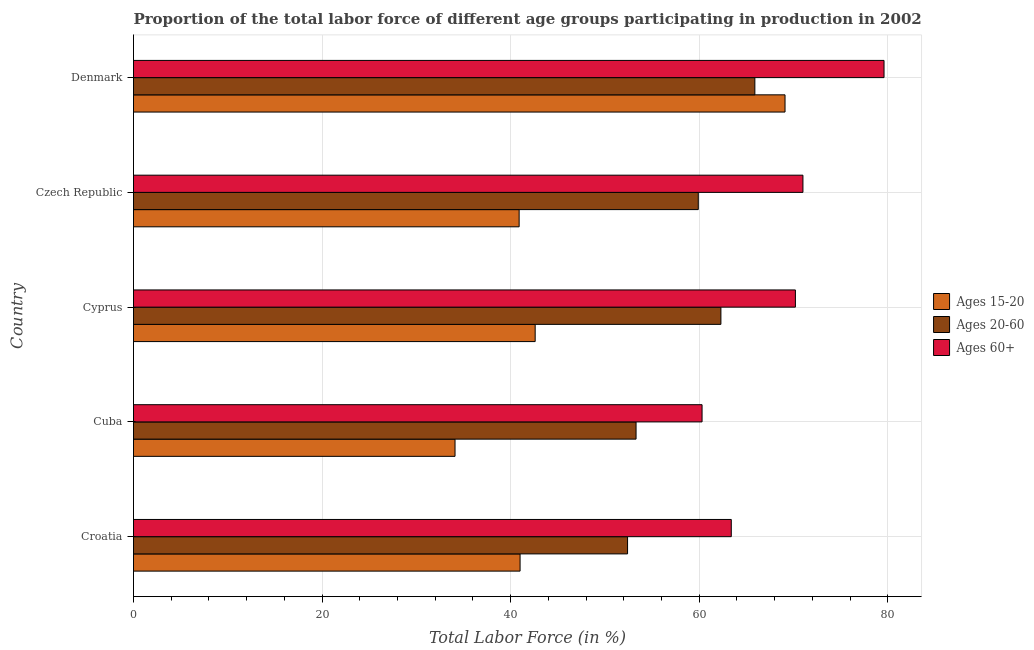Are the number of bars on each tick of the Y-axis equal?
Offer a terse response. Yes. How many bars are there on the 5th tick from the top?
Offer a very short reply. 3. How many bars are there on the 1st tick from the bottom?
Keep it short and to the point. 3. What is the label of the 4th group of bars from the top?
Provide a succinct answer. Cuba. In how many cases, is the number of bars for a given country not equal to the number of legend labels?
Offer a very short reply. 0. What is the percentage of labor force within the age group 20-60 in Denmark?
Your answer should be compact. 65.9. Across all countries, what is the maximum percentage of labor force above age 60?
Give a very brief answer. 79.6. Across all countries, what is the minimum percentage of labor force above age 60?
Ensure brevity in your answer.  60.3. In which country was the percentage of labor force within the age group 20-60 maximum?
Provide a succinct answer. Denmark. In which country was the percentage of labor force within the age group 20-60 minimum?
Offer a terse response. Croatia. What is the total percentage of labor force above age 60 in the graph?
Your response must be concise. 344.5. What is the difference between the percentage of labor force within the age group 20-60 in Croatia and the percentage of labor force above age 60 in Denmark?
Provide a succinct answer. -27.2. What is the average percentage of labor force within the age group 20-60 per country?
Your response must be concise. 58.76. What is the difference between the percentage of labor force above age 60 and percentage of labor force within the age group 15-20 in Cyprus?
Your response must be concise. 27.6. Is the percentage of labor force above age 60 in Croatia less than that in Cuba?
Offer a very short reply. No. What is the difference between the highest and the second highest percentage of labor force within the age group 20-60?
Make the answer very short. 3.6. What is the difference between the highest and the lowest percentage of labor force above age 60?
Keep it short and to the point. 19.3. In how many countries, is the percentage of labor force within the age group 20-60 greater than the average percentage of labor force within the age group 20-60 taken over all countries?
Offer a terse response. 3. What does the 2nd bar from the top in Cuba represents?
Your answer should be compact. Ages 20-60. What does the 2nd bar from the bottom in Cyprus represents?
Your answer should be compact. Ages 20-60. Is it the case that in every country, the sum of the percentage of labor force within the age group 15-20 and percentage of labor force within the age group 20-60 is greater than the percentage of labor force above age 60?
Make the answer very short. Yes. How many bars are there?
Ensure brevity in your answer.  15. How many countries are there in the graph?
Offer a terse response. 5. What is the difference between two consecutive major ticks on the X-axis?
Give a very brief answer. 20. Does the graph contain grids?
Give a very brief answer. Yes. How many legend labels are there?
Your response must be concise. 3. How are the legend labels stacked?
Your answer should be very brief. Vertical. What is the title of the graph?
Offer a terse response. Proportion of the total labor force of different age groups participating in production in 2002. What is the label or title of the X-axis?
Provide a succinct answer. Total Labor Force (in %). What is the label or title of the Y-axis?
Provide a short and direct response. Country. What is the Total Labor Force (in %) of Ages 20-60 in Croatia?
Keep it short and to the point. 52.4. What is the Total Labor Force (in %) of Ages 60+ in Croatia?
Provide a short and direct response. 63.4. What is the Total Labor Force (in %) in Ages 15-20 in Cuba?
Make the answer very short. 34.1. What is the Total Labor Force (in %) of Ages 20-60 in Cuba?
Your answer should be very brief. 53.3. What is the Total Labor Force (in %) in Ages 60+ in Cuba?
Provide a succinct answer. 60.3. What is the Total Labor Force (in %) of Ages 15-20 in Cyprus?
Provide a short and direct response. 42.6. What is the Total Labor Force (in %) in Ages 20-60 in Cyprus?
Keep it short and to the point. 62.3. What is the Total Labor Force (in %) of Ages 60+ in Cyprus?
Ensure brevity in your answer.  70.2. What is the Total Labor Force (in %) in Ages 15-20 in Czech Republic?
Ensure brevity in your answer.  40.9. What is the Total Labor Force (in %) of Ages 20-60 in Czech Republic?
Your response must be concise. 59.9. What is the Total Labor Force (in %) in Ages 60+ in Czech Republic?
Your answer should be very brief. 71. What is the Total Labor Force (in %) of Ages 15-20 in Denmark?
Your answer should be compact. 69.1. What is the Total Labor Force (in %) in Ages 20-60 in Denmark?
Your answer should be very brief. 65.9. What is the Total Labor Force (in %) in Ages 60+ in Denmark?
Offer a terse response. 79.6. Across all countries, what is the maximum Total Labor Force (in %) of Ages 15-20?
Your answer should be very brief. 69.1. Across all countries, what is the maximum Total Labor Force (in %) of Ages 20-60?
Make the answer very short. 65.9. Across all countries, what is the maximum Total Labor Force (in %) in Ages 60+?
Your response must be concise. 79.6. Across all countries, what is the minimum Total Labor Force (in %) in Ages 15-20?
Give a very brief answer. 34.1. Across all countries, what is the minimum Total Labor Force (in %) of Ages 20-60?
Provide a succinct answer. 52.4. Across all countries, what is the minimum Total Labor Force (in %) in Ages 60+?
Offer a terse response. 60.3. What is the total Total Labor Force (in %) of Ages 15-20 in the graph?
Your response must be concise. 227.7. What is the total Total Labor Force (in %) in Ages 20-60 in the graph?
Give a very brief answer. 293.8. What is the total Total Labor Force (in %) of Ages 60+ in the graph?
Ensure brevity in your answer.  344.5. What is the difference between the Total Labor Force (in %) of Ages 15-20 in Croatia and that in Cuba?
Ensure brevity in your answer.  6.9. What is the difference between the Total Labor Force (in %) of Ages 20-60 in Croatia and that in Cuba?
Ensure brevity in your answer.  -0.9. What is the difference between the Total Labor Force (in %) of Ages 60+ in Croatia and that in Cuba?
Give a very brief answer. 3.1. What is the difference between the Total Labor Force (in %) of Ages 15-20 in Croatia and that in Cyprus?
Offer a very short reply. -1.6. What is the difference between the Total Labor Force (in %) of Ages 15-20 in Croatia and that in Czech Republic?
Your response must be concise. 0.1. What is the difference between the Total Labor Force (in %) in Ages 20-60 in Croatia and that in Czech Republic?
Provide a succinct answer. -7.5. What is the difference between the Total Labor Force (in %) in Ages 60+ in Croatia and that in Czech Republic?
Give a very brief answer. -7.6. What is the difference between the Total Labor Force (in %) of Ages 15-20 in Croatia and that in Denmark?
Give a very brief answer. -28.1. What is the difference between the Total Labor Force (in %) of Ages 60+ in Croatia and that in Denmark?
Your response must be concise. -16.2. What is the difference between the Total Labor Force (in %) of Ages 15-20 in Cuba and that in Cyprus?
Your answer should be compact. -8.5. What is the difference between the Total Labor Force (in %) in Ages 60+ in Cuba and that in Cyprus?
Offer a terse response. -9.9. What is the difference between the Total Labor Force (in %) of Ages 20-60 in Cuba and that in Czech Republic?
Offer a very short reply. -6.6. What is the difference between the Total Labor Force (in %) in Ages 15-20 in Cuba and that in Denmark?
Your response must be concise. -35. What is the difference between the Total Labor Force (in %) of Ages 20-60 in Cuba and that in Denmark?
Offer a very short reply. -12.6. What is the difference between the Total Labor Force (in %) in Ages 60+ in Cuba and that in Denmark?
Offer a terse response. -19.3. What is the difference between the Total Labor Force (in %) of Ages 15-20 in Cyprus and that in Czech Republic?
Your answer should be very brief. 1.7. What is the difference between the Total Labor Force (in %) in Ages 60+ in Cyprus and that in Czech Republic?
Offer a terse response. -0.8. What is the difference between the Total Labor Force (in %) of Ages 15-20 in Cyprus and that in Denmark?
Provide a short and direct response. -26.5. What is the difference between the Total Labor Force (in %) in Ages 20-60 in Cyprus and that in Denmark?
Provide a succinct answer. -3.6. What is the difference between the Total Labor Force (in %) in Ages 60+ in Cyprus and that in Denmark?
Give a very brief answer. -9.4. What is the difference between the Total Labor Force (in %) in Ages 15-20 in Czech Republic and that in Denmark?
Provide a succinct answer. -28.2. What is the difference between the Total Labor Force (in %) in Ages 60+ in Czech Republic and that in Denmark?
Your answer should be very brief. -8.6. What is the difference between the Total Labor Force (in %) of Ages 15-20 in Croatia and the Total Labor Force (in %) of Ages 60+ in Cuba?
Keep it short and to the point. -19.3. What is the difference between the Total Labor Force (in %) of Ages 15-20 in Croatia and the Total Labor Force (in %) of Ages 20-60 in Cyprus?
Offer a terse response. -21.3. What is the difference between the Total Labor Force (in %) in Ages 15-20 in Croatia and the Total Labor Force (in %) in Ages 60+ in Cyprus?
Your answer should be very brief. -29.2. What is the difference between the Total Labor Force (in %) in Ages 20-60 in Croatia and the Total Labor Force (in %) in Ages 60+ in Cyprus?
Ensure brevity in your answer.  -17.8. What is the difference between the Total Labor Force (in %) in Ages 15-20 in Croatia and the Total Labor Force (in %) in Ages 20-60 in Czech Republic?
Your answer should be very brief. -18.9. What is the difference between the Total Labor Force (in %) of Ages 20-60 in Croatia and the Total Labor Force (in %) of Ages 60+ in Czech Republic?
Ensure brevity in your answer.  -18.6. What is the difference between the Total Labor Force (in %) in Ages 15-20 in Croatia and the Total Labor Force (in %) in Ages 20-60 in Denmark?
Provide a succinct answer. -24.9. What is the difference between the Total Labor Force (in %) in Ages 15-20 in Croatia and the Total Labor Force (in %) in Ages 60+ in Denmark?
Your response must be concise. -38.6. What is the difference between the Total Labor Force (in %) of Ages 20-60 in Croatia and the Total Labor Force (in %) of Ages 60+ in Denmark?
Give a very brief answer. -27.2. What is the difference between the Total Labor Force (in %) in Ages 15-20 in Cuba and the Total Labor Force (in %) in Ages 20-60 in Cyprus?
Keep it short and to the point. -28.2. What is the difference between the Total Labor Force (in %) in Ages 15-20 in Cuba and the Total Labor Force (in %) in Ages 60+ in Cyprus?
Give a very brief answer. -36.1. What is the difference between the Total Labor Force (in %) of Ages 20-60 in Cuba and the Total Labor Force (in %) of Ages 60+ in Cyprus?
Keep it short and to the point. -16.9. What is the difference between the Total Labor Force (in %) of Ages 15-20 in Cuba and the Total Labor Force (in %) of Ages 20-60 in Czech Republic?
Ensure brevity in your answer.  -25.8. What is the difference between the Total Labor Force (in %) of Ages 15-20 in Cuba and the Total Labor Force (in %) of Ages 60+ in Czech Republic?
Make the answer very short. -36.9. What is the difference between the Total Labor Force (in %) of Ages 20-60 in Cuba and the Total Labor Force (in %) of Ages 60+ in Czech Republic?
Provide a succinct answer. -17.7. What is the difference between the Total Labor Force (in %) of Ages 15-20 in Cuba and the Total Labor Force (in %) of Ages 20-60 in Denmark?
Your response must be concise. -31.8. What is the difference between the Total Labor Force (in %) in Ages 15-20 in Cuba and the Total Labor Force (in %) in Ages 60+ in Denmark?
Offer a terse response. -45.5. What is the difference between the Total Labor Force (in %) in Ages 20-60 in Cuba and the Total Labor Force (in %) in Ages 60+ in Denmark?
Your response must be concise. -26.3. What is the difference between the Total Labor Force (in %) of Ages 15-20 in Cyprus and the Total Labor Force (in %) of Ages 20-60 in Czech Republic?
Provide a short and direct response. -17.3. What is the difference between the Total Labor Force (in %) of Ages 15-20 in Cyprus and the Total Labor Force (in %) of Ages 60+ in Czech Republic?
Keep it short and to the point. -28.4. What is the difference between the Total Labor Force (in %) in Ages 15-20 in Cyprus and the Total Labor Force (in %) in Ages 20-60 in Denmark?
Provide a short and direct response. -23.3. What is the difference between the Total Labor Force (in %) in Ages 15-20 in Cyprus and the Total Labor Force (in %) in Ages 60+ in Denmark?
Ensure brevity in your answer.  -37. What is the difference between the Total Labor Force (in %) in Ages 20-60 in Cyprus and the Total Labor Force (in %) in Ages 60+ in Denmark?
Ensure brevity in your answer.  -17.3. What is the difference between the Total Labor Force (in %) in Ages 15-20 in Czech Republic and the Total Labor Force (in %) in Ages 20-60 in Denmark?
Provide a succinct answer. -25. What is the difference between the Total Labor Force (in %) in Ages 15-20 in Czech Republic and the Total Labor Force (in %) in Ages 60+ in Denmark?
Provide a short and direct response. -38.7. What is the difference between the Total Labor Force (in %) of Ages 20-60 in Czech Republic and the Total Labor Force (in %) of Ages 60+ in Denmark?
Provide a short and direct response. -19.7. What is the average Total Labor Force (in %) of Ages 15-20 per country?
Offer a very short reply. 45.54. What is the average Total Labor Force (in %) in Ages 20-60 per country?
Give a very brief answer. 58.76. What is the average Total Labor Force (in %) in Ages 60+ per country?
Keep it short and to the point. 68.9. What is the difference between the Total Labor Force (in %) in Ages 15-20 and Total Labor Force (in %) in Ages 60+ in Croatia?
Keep it short and to the point. -22.4. What is the difference between the Total Labor Force (in %) in Ages 20-60 and Total Labor Force (in %) in Ages 60+ in Croatia?
Keep it short and to the point. -11. What is the difference between the Total Labor Force (in %) of Ages 15-20 and Total Labor Force (in %) of Ages 20-60 in Cuba?
Your response must be concise. -19.2. What is the difference between the Total Labor Force (in %) of Ages 15-20 and Total Labor Force (in %) of Ages 60+ in Cuba?
Keep it short and to the point. -26.2. What is the difference between the Total Labor Force (in %) in Ages 15-20 and Total Labor Force (in %) in Ages 20-60 in Cyprus?
Make the answer very short. -19.7. What is the difference between the Total Labor Force (in %) of Ages 15-20 and Total Labor Force (in %) of Ages 60+ in Cyprus?
Provide a short and direct response. -27.6. What is the difference between the Total Labor Force (in %) of Ages 15-20 and Total Labor Force (in %) of Ages 60+ in Czech Republic?
Provide a succinct answer. -30.1. What is the difference between the Total Labor Force (in %) of Ages 15-20 and Total Labor Force (in %) of Ages 20-60 in Denmark?
Provide a succinct answer. 3.2. What is the difference between the Total Labor Force (in %) of Ages 20-60 and Total Labor Force (in %) of Ages 60+ in Denmark?
Your answer should be very brief. -13.7. What is the ratio of the Total Labor Force (in %) in Ages 15-20 in Croatia to that in Cuba?
Make the answer very short. 1.2. What is the ratio of the Total Labor Force (in %) in Ages 20-60 in Croatia to that in Cuba?
Make the answer very short. 0.98. What is the ratio of the Total Labor Force (in %) in Ages 60+ in Croatia to that in Cuba?
Keep it short and to the point. 1.05. What is the ratio of the Total Labor Force (in %) in Ages 15-20 in Croatia to that in Cyprus?
Offer a terse response. 0.96. What is the ratio of the Total Labor Force (in %) of Ages 20-60 in Croatia to that in Cyprus?
Offer a terse response. 0.84. What is the ratio of the Total Labor Force (in %) in Ages 60+ in Croatia to that in Cyprus?
Offer a terse response. 0.9. What is the ratio of the Total Labor Force (in %) of Ages 15-20 in Croatia to that in Czech Republic?
Make the answer very short. 1. What is the ratio of the Total Labor Force (in %) in Ages 20-60 in Croatia to that in Czech Republic?
Your answer should be compact. 0.87. What is the ratio of the Total Labor Force (in %) of Ages 60+ in Croatia to that in Czech Republic?
Make the answer very short. 0.89. What is the ratio of the Total Labor Force (in %) in Ages 15-20 in Croatia to that in Denmark?
Provide a succinct answer. 0.59. What is the ratio of the Total Labor Force (in %) in Ages 20-60 in Croatia to that in Denmark?
Your answer should be very brief. 0.8. What is the ratio of the Total Labor Force (in %) in Ages 60+ in Croatia to that in Denmark?
Ensure brevity in your answer.  0.8. What is the ratio of the Total Labor Force (in %) of Ages 15-20 in Cuba to that in Cyprus?
Offer a very short reply. 0.8. What is the ratio of the Total Labor Force (in %) of Ages 20-60 in Cuba to that in Cyprus?
Provide a short and direct response. 0.86. What is the ratio of the Total Labor Force (in %) of Ages 60+ in Cuba to that in Cyprus?
Ensure brevity in your answer.  0.86. What is the ratio of the Total Labor Force (in %) in Ages 15-20 in Cuba to that in Czech Republic?
Give a very brief answer. 0.83. What is the ratio of the Total Labor Force (in %) in Ages 20-60 in Cuba to that in Czech Republic?
Offer a terse response. 0.89. What is the ratio of the Total Labor Force (in %) in Ages 60+ in Cuba to that in Czech Republic?
Offer a terse response. 0.85. What is the ratio of the Total Labor Force (in %) in Ages 15-20 in Cuba to that in Denmark?
Make the answer very short. 0.49. What is the ratio of the Total Labor Force (in %) of Ages 20-60 in Cuba to that in Denmark?
Your response must be concise. 0.81. What is the ratio of the Total Labor Force (in %) in Ages 60+ in Cuba to that in Denmark?
Offer a very short reply. 0.76. What is the ratio of the Total Labor Force (in %) of Ages 15-20 in Cyprus to that in Czech Republic?
Provide a short and direct response. 1.04. What is the ratio of the Total Labor Force (in %) of Ages 20-60 in Cyprus to that in Czech Republic?
Provide a short and direct response. 1.04. What is the ratio of the Total Labor Force (in %) of Ages 60+ in Cyprus to that in Czech Republic?
Ensure brevity in your answer.  0.99. What is the ratio of the Total Labor Force (in %) of Ages 15-20 in Cyprus to that in Denmark?
Ensure brevity in your answer.  0.62. What is the ratio of the Total Labor Force (in %) of Ages 20-60 in Cyprus to that in Denmark?
Offer a terse response. 0.95. What is the ratio of the Total Labor Force (in %) in Ages 60+ in Cyprus to that in Denmark?
Offer a terse response. 0.88. What is the ratio of the Total Labor Force (in %) in Ages 15-20 in Czech Republic to that in Denmark?
Offer a very short reply. 0.59. What is the ratio of the Total Labor Force (in %) of Ages 20-60 in Czech Republic to that in Denmark?
Make the answer very short. 0.91. What is the ratio of the Total Labor Force (in %) in Ages 60+ in Czech Republic to that in Denmark?
Offer a terse response. 0.89. What is the difference between the highest and the lowest Total Labor Force (in %) of Ages 15-20?
Offer a very short reply. 35. What is the difference between the highest and the lowest Total Labor Force (in %) of Ages 20-60?
Provide a short and direct response. 13.5. What is the difference between the highest and the lowest Total Labor Force (in %) in Ages 60+?
Your answer should be very brief. 19.3. 